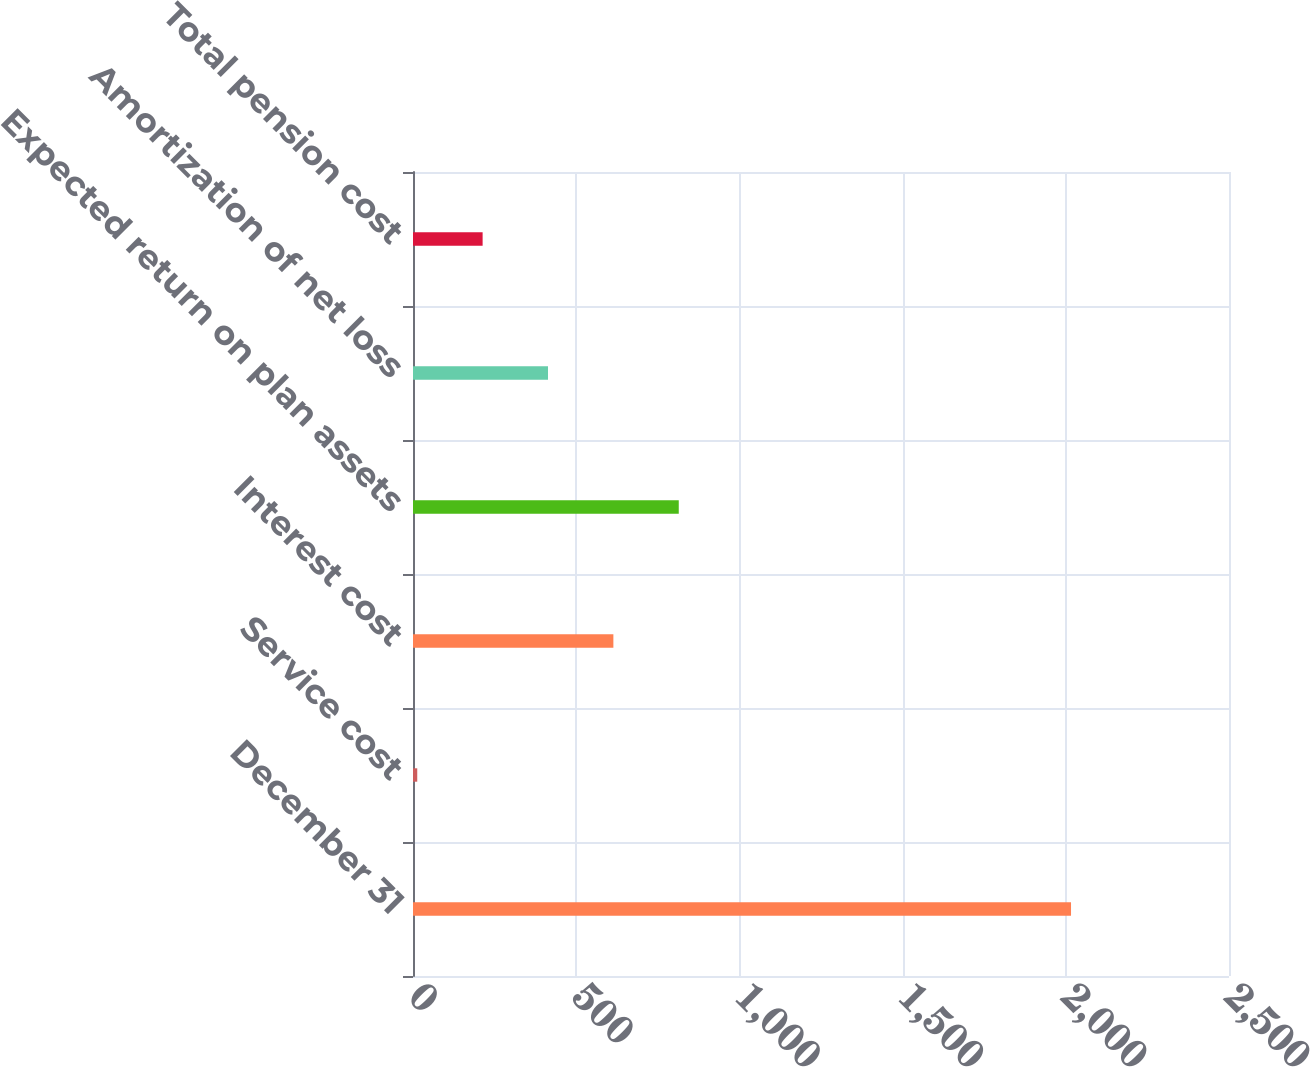<chart> <loc_0><loc_0><loc_500><loc_500><bar_chart><fcel>December 31<fcel>Service cost<fcel>Interest cost<fcel>Expected return on plan assets<fcel>Amortization of net loss<fcel>Total pension cost<nl><fcel>2016<fcel>13<fcel>613.9<fcel>814.2<fcel>413.6<fcel>213.3<nl></chart> 